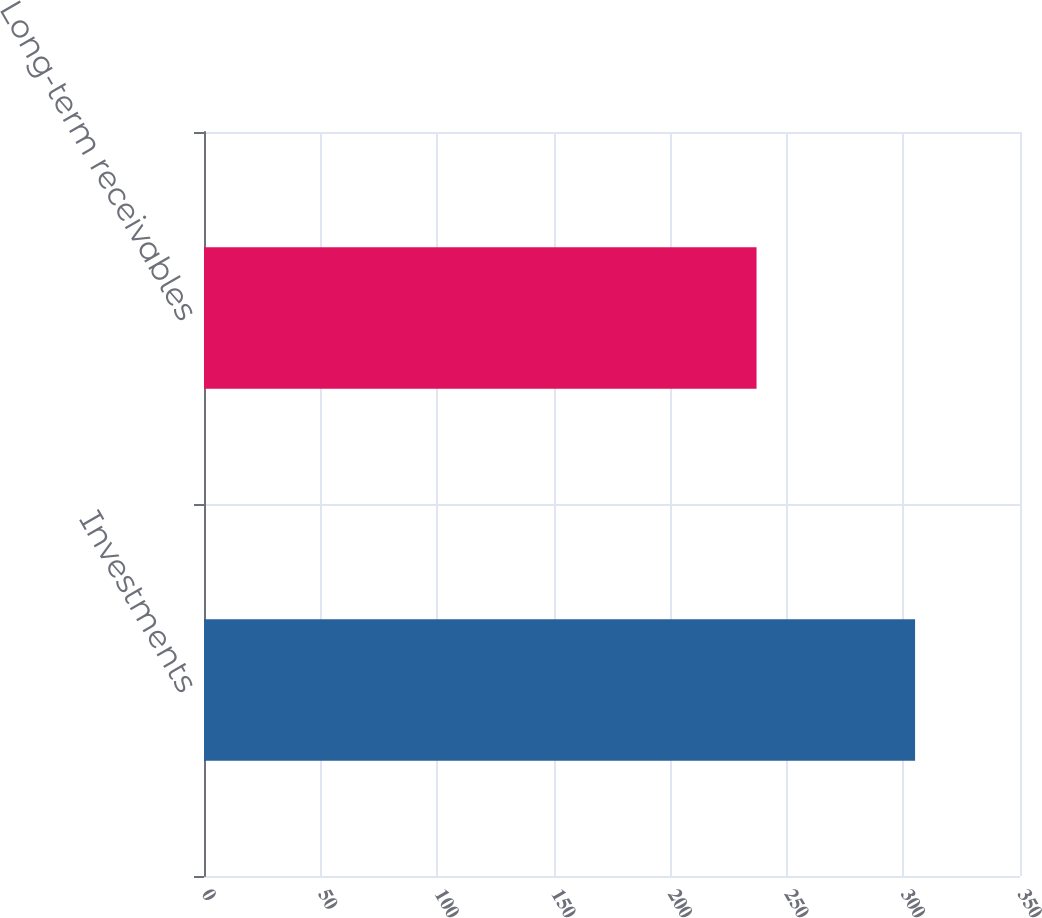Convert chart. <chart><loc_0><loc_0><loc_500><loc_500><bar_chart><fcel>Investments<fcel>Long-term receivables<nl><fcel>305<fcel>237<nl></chart> 